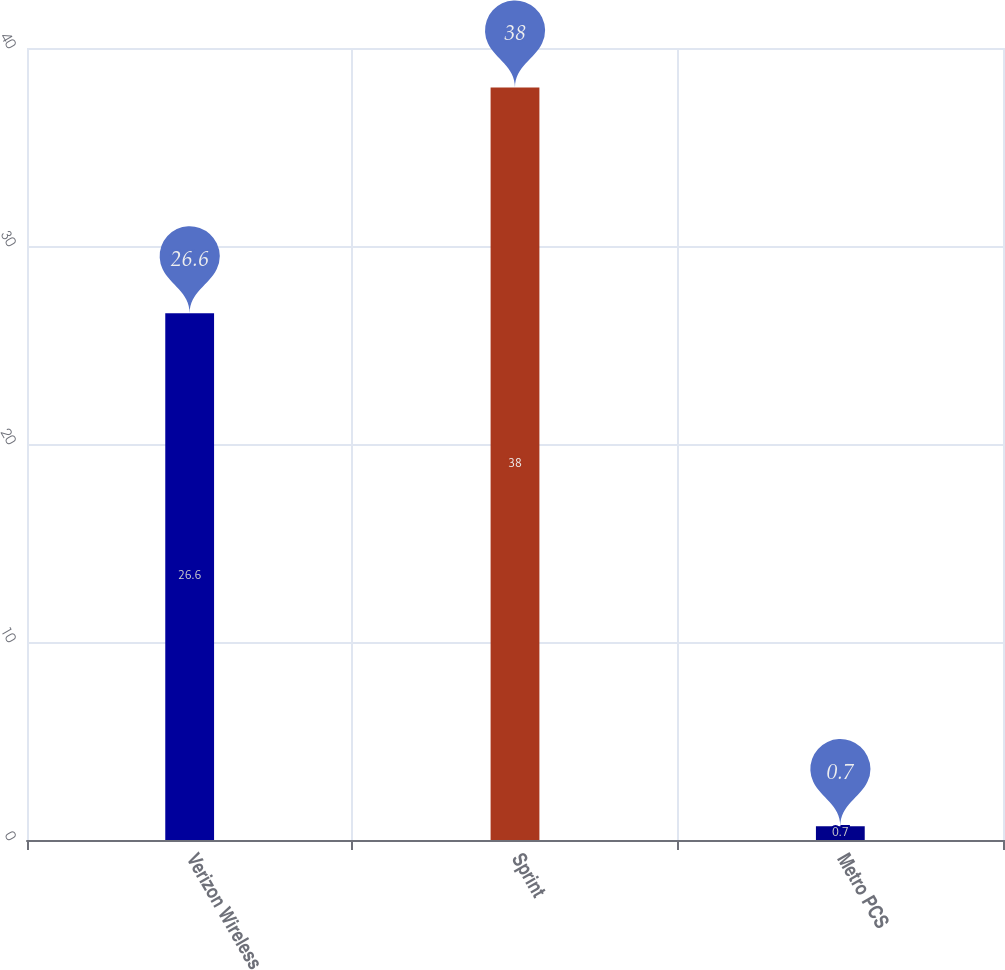Convert chart to OTSL. <chart><loc_0><loc_0><loc_500><loc_500><bar_chart><fcel>Verizon Wireless<fcel>Sprint<fcel>Metro PCS<nl><fcel>26.6<fcel>38<fcel>0.7<nl></chart> 